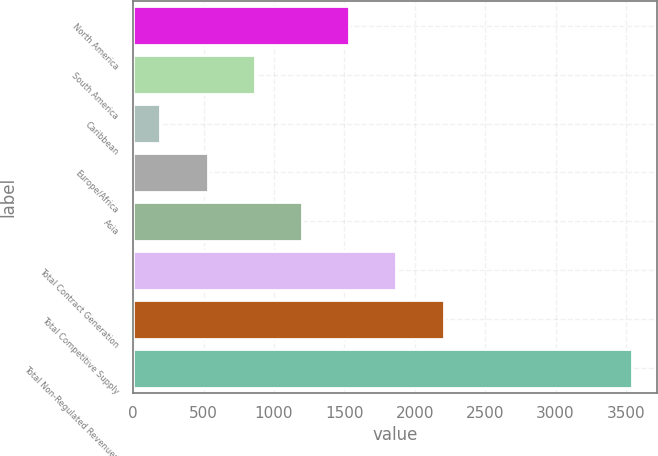<chart> <loc_0><loc_0><loc_500><loc_500><bar_chart><fcel>North America<fcel>South America<fcel>Caribbean<fcel>Europe/Africa<fcel>Asia<fcel>Total Contract Generation<fcel>Total Competitive Supply<fcel>Total Non-Regulated Revenues<nl><fcel>1533.8<fcel>863.4<fcel>193<fcel>528.2<fcel>1198.6<fcel>1869<fcel>2204.2<fcel>3545<nl></chart> 